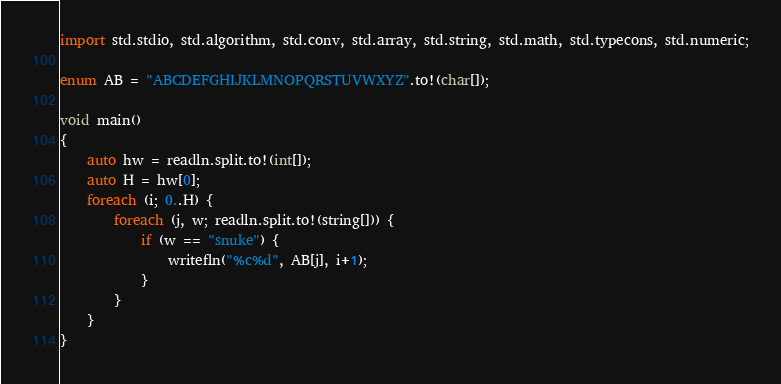Convert code to text. <code><loc_0><loc_0><loc_500><loc_500><_D_>import std.stdio, std.algorithm, std.conv, std.array, std.string, std.math, std.typecons, std.numeric;

enum AB = "ABCDEFGHIJKLMNOPQRSTUVWXYZ".to!(char[]);

void main()
{
    auto hw = readln.split.to!(int[]);
    auto H = hw[0];
    foreach (i; 0..H) {
        foreach (j, w; readln.split.to!(string[])) {
            if (w == "snuke") {
                writefln("%c%d", AB[j], i+1);
            }
        }
    }
}</code> 